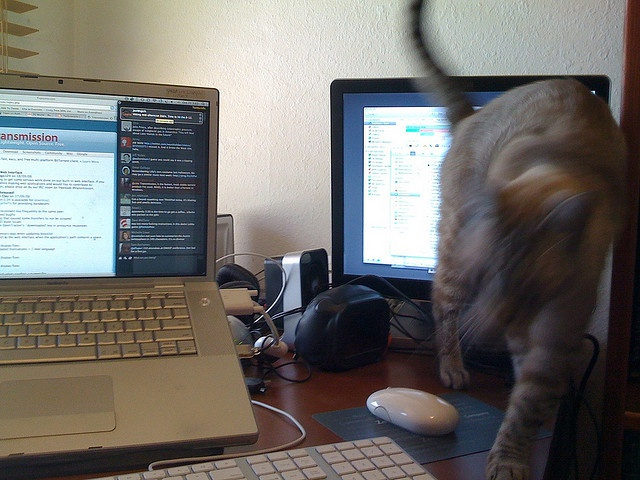Describe the objects in this image and their specific colors. I can see laptop in olive, gray, lightblue, and black tones, cat in olive, black, and gray tones, tv in olive, white, black, gray, and blue tones, keyboard in olive, gray, and black tones, and keyboard in olive and gray tones in this image. 